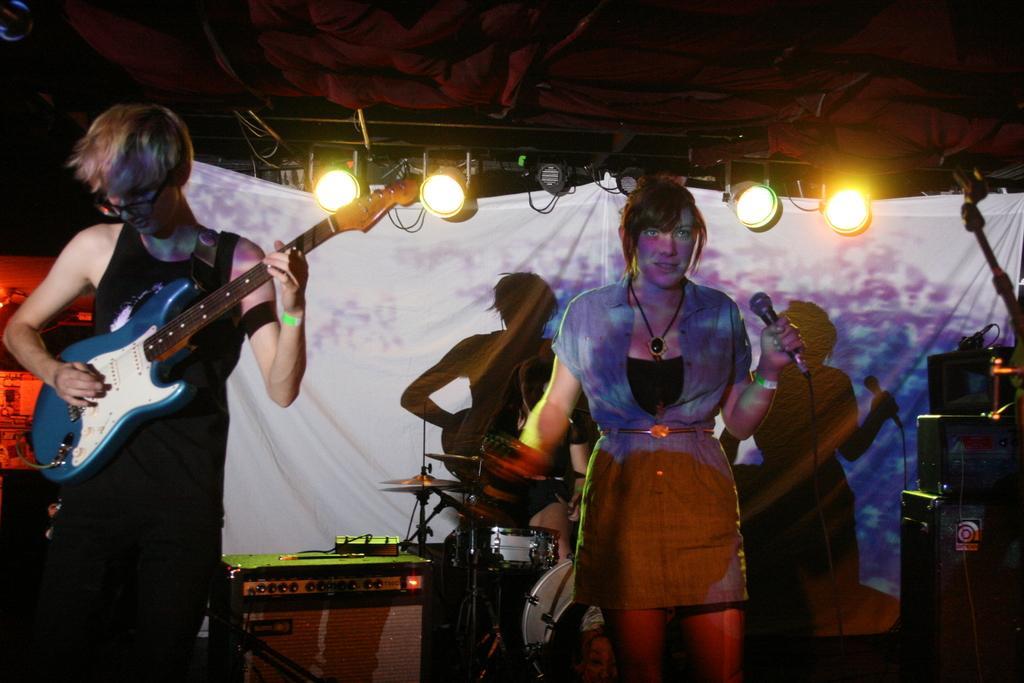In one or two sentences, can you explain what this image depicts? Front this person is playing a guitar and wore spectacles. On top there are focusing lights. This woman is holding a mic. These are musical instruments. These are speakers. 